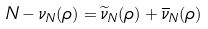Convert formula to latex. <formula><loc_0><loc_0><loc_500><loc_500>N - \nu _ { N } ( \rho ) = \widetilde { \nu } _ { N } ( \rho ) + \overline { \nu } _ { N } ( \rho )</formula> 